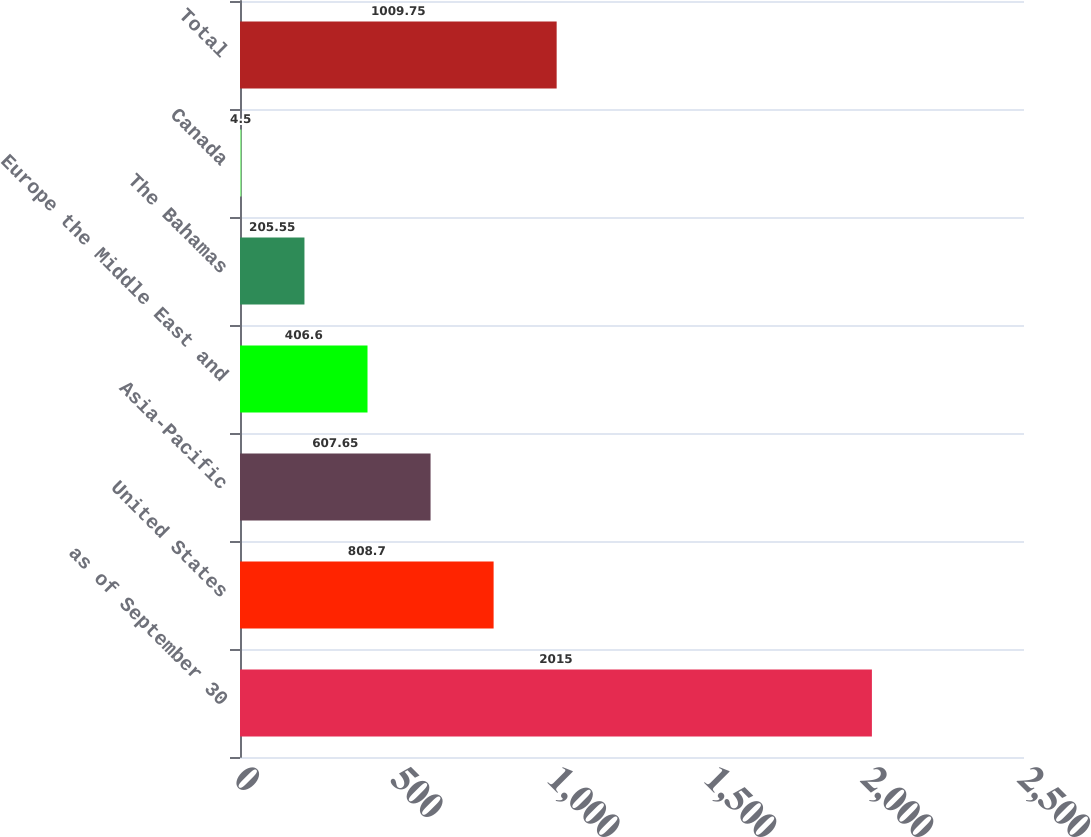<chart> <loc_0><loc_0><loc_500><loc_500><bar_chart><fcel>as of September 30<fcel>United States<fcel>Asia-Pacific<fcel>Europe the Middle East and<fcel>The Bahamas<fcel>Canada<fcel>Total<nl><fcel>2015<fcel>808.7<fcel>607.65<fcel>406.6<fcel>205.55<fcel>4.5<fcel>1009.75<nl></chart> 